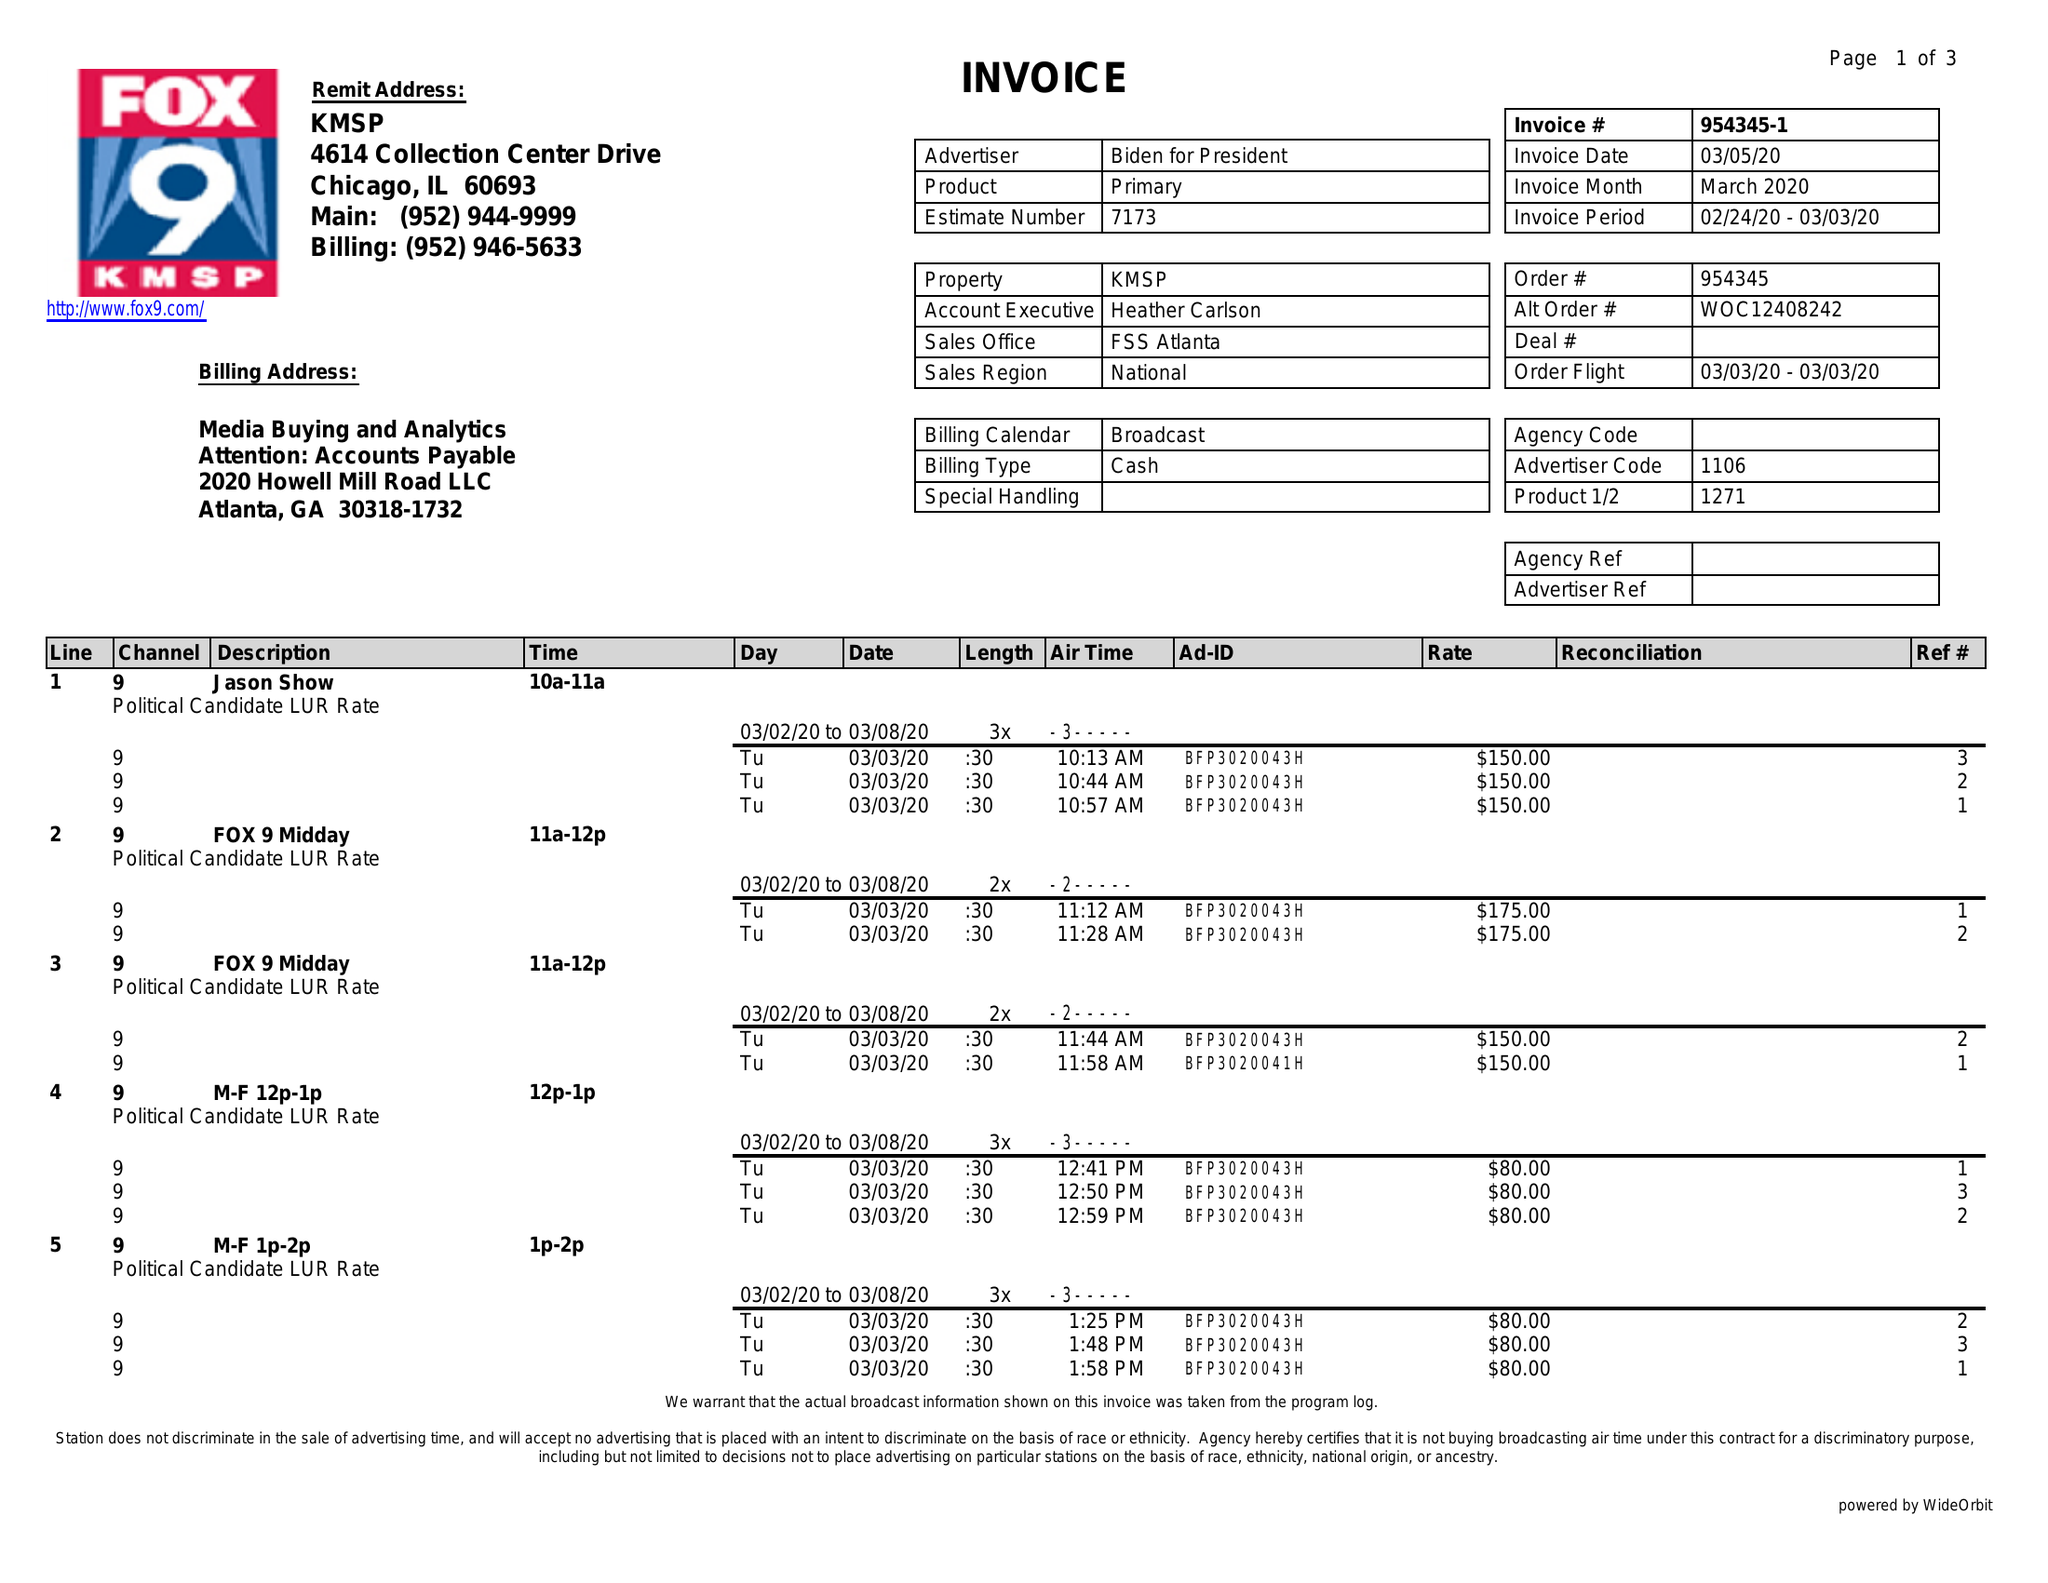What is the value for the flight_to?
Answer the question using a single word or phrase. 03/03/20 